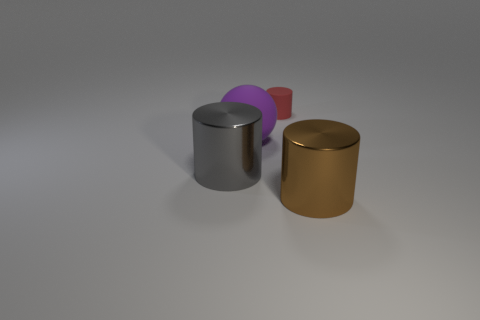Subtract all large cylinders. How many cylinders are left? 1 Add 2 tiny red rubber cylinders. How many objects exist? 6 Subtract all cylinders. How many objects are left? 1 Add 1 metallic blocks. How many metallic blocks exist? 1 Subtract 0 purple blocks. How many objects are left? 4 Subtract all tiny cylinders. Subtract all gray shiny objects. How many objects are left? 2 Add 2 balls. How many balls are left? 3 